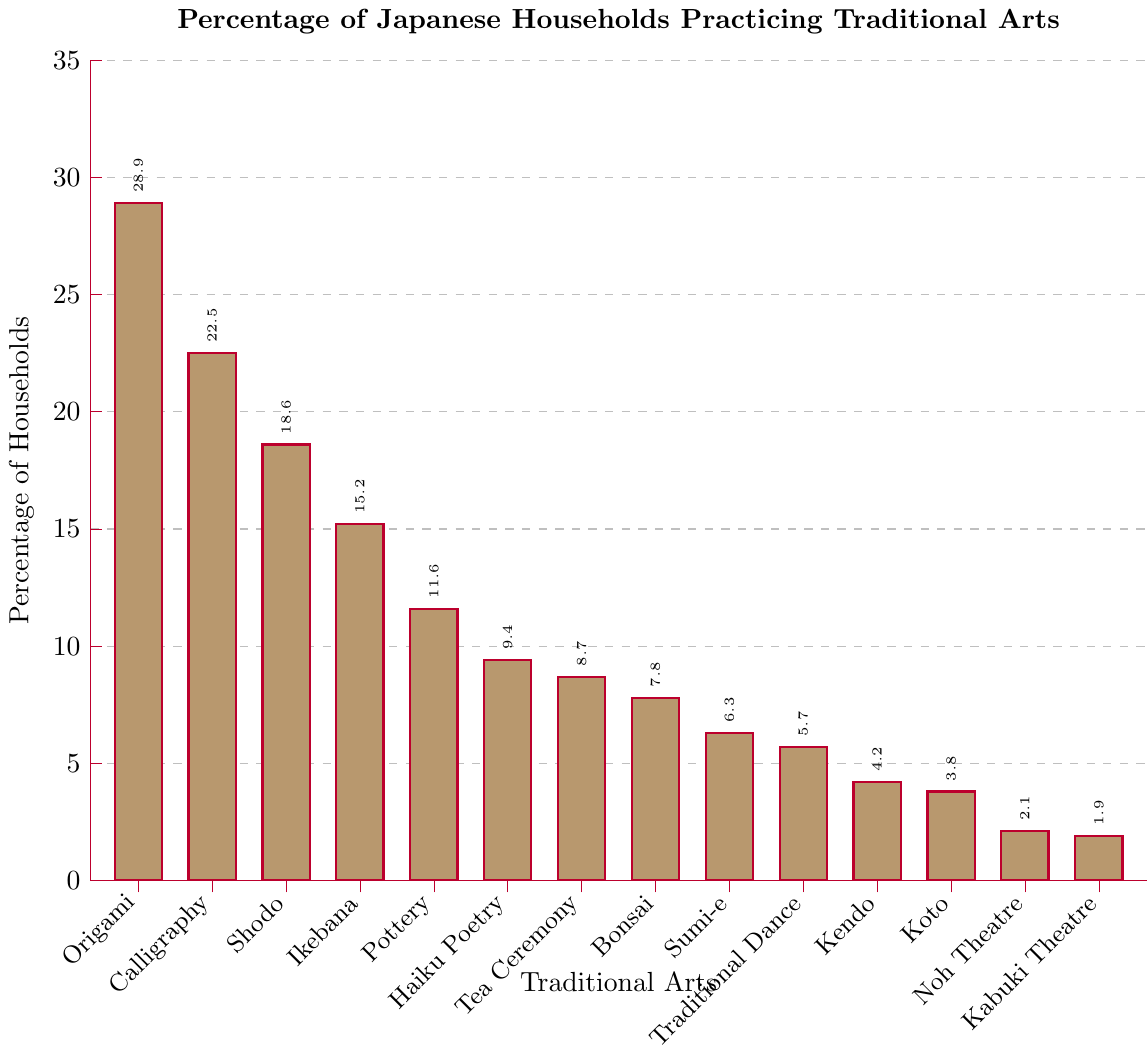Which traditional art has the highest percentage of Japanese households practicing it? From the bar chart, look for the tallest bar, which represents the traditional art with the highest percentage. This is marked with 28.9% for Origami.
Answer: Origami Which two traditional arts have the closest percentages? From the bar chart, find two bars with similar heights. In this case, Noh Theatre (2.1%) and Kabuki Theatre (1.9%) are very close to each other.
Answer: Noh Theatre and Kabuki Theatre How much higher is the percentage of households practicing Calligraphy compared to Sumi-e? Look at the bar height for Calligraphy (22.5%) and Sumi-e (6.3%). Subtract Sumi-e’s percentage from Calligraphy’s: 22.5% - 6.3% = 16.2%.
Answer: 16.2% What is the combined percentage of households practicing Ikebana and Haiku Poetry? Find the bars representing Ikebana (15.2%) and Haiku Poetry (9.4%), then add their percentages: 15.2% + 9.4% = 24.6%.
Answer: 24.6% Rank the top three traditional arts by the percentage of households practicing them. Identify the three tallest bars from the chart, which are Origami (28.9%), Calligraphy (22.5%), and Shodo (18.6%).
Answer: Origami, Calligraphy, Shodo Which traditional art has a percentage closest to 10%? From the bar chart, look for the bar closest to the 10% mark. Haiku Poetry has 9.4%, which is the closest.
Answer: Haiku Poetry What is the difference in percentage between the highest and the lowest traditional arts practiced? Identify the highest percentage (Origami at 28.9%) and the lowest percentage (Kabuki Theatre at 1.9%). Subtract the lowest from the highest: 28.9% - 1.9% = 27.0%.
Answer: 27.0% How many traditional arts have a percentage greater than 10%? Count the bars with percentages higher than 10%: Origami (28.9%), Calligraphy (22.5%), Shodo (18.6%), Ikebana (15.2%), and Pottery (11.6%). There are 5 bars.
Answer: 5 Calculate the average percentage of households practicing Tea Ceremony, Bonsai, and Kendo. Find the percentages for Tea Ceremony (8.7%), Bonsai (7.8%), and Kendo (4.2%). Sum these values and divide by 3: (8.7% + 7.8% + 4.2%) / 3 = 6.9%.
Answer: 6.9% Which traditional arts have percentages less than 5%? Identify the bars with percentages below 5%: Kendo (4.2%), Koto (3.8%), Noh Theatre (2.1%), and Kabuki Theatre (1.9%).
Answer: Kendo, Koto, Noh Theatre, Kabuki Theatre 